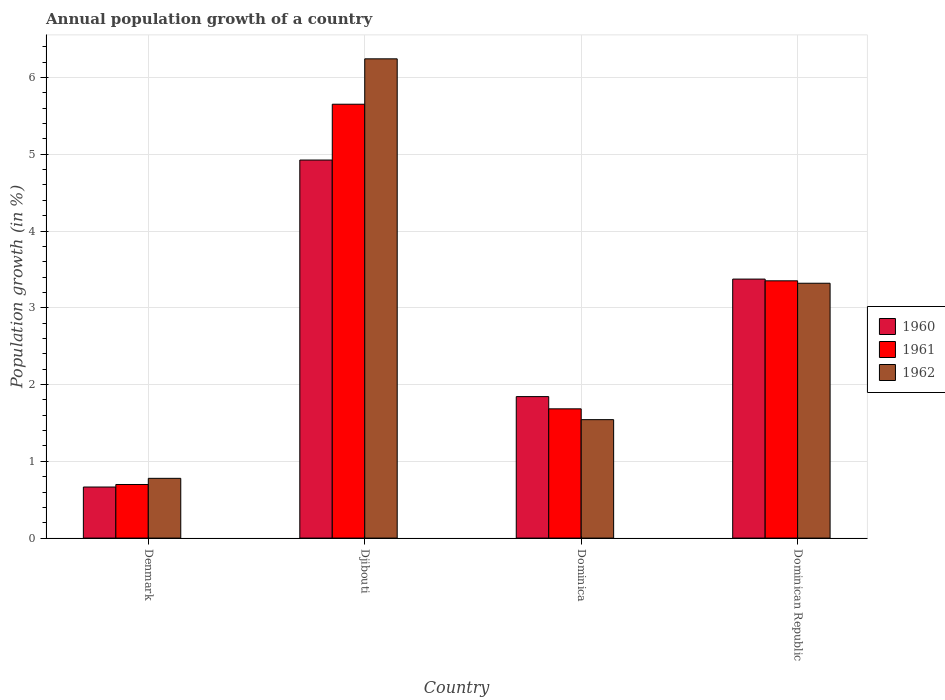How many different coloured bars are there?
Your answer should be very brief. 3. How many groups of bars are there?
Give a very brief answer. 4. How many bars are there on the 4th tick from the left?
Offer a very short reply. 3. What is the label of the 3rd group of bars from the left?
Offer a terse response. Dominica. What is the annual population growth in 1962 in Dominica?
Your answer should be compact. 1.54. Across all countries, what is the maximum annual population growth in 1961?
Give a very brief answer. 5.65. Across all countries, what is the minimum annual population growth in 1961?
Ensure brevity in your answer.  0.7. In which country was the annual population growth in 1961 maximum?
Provide a short and direct response. Djibouti. What is the total annual population growth in 1960 in the graph?
Offer a terse response. 10.81. What is the difference between the annual population growth in 1960 in Djibouti and that in Dominica?
Your answer should be very brief. 3.08. What is the difference between the annual population growth in 1960 in Dominican Republic and the annual population growth in 1962 in Dominica?
Make the answer very short. 1.83. What is the average annual population growth in 1961 per country?
Your answer should be very brief. 2.85. What is the difference between the annual population growth of/in 1962 and annual population growth of/in 1961 in Denmark?
Your answer should be very brief. 0.08. What is the ratio of the annual population growth in 1960 in Denmark to that in Djibouti?
Make the answer very short. 0.14. Is the difference between the annual population growth in 1962 in Dominica and Dominican Republic greater than the difference between the annual population growth in 1961 in Dominica and Dominican Republic?
Keep it short and to the point. No. What is the difference between the highest and the second highest annual population growth in 1961?
Your response must be concise. -1.67. What is the difference between the highest and the lowest annual population growth in 1961?
Make the answer very short. 4.95. How many bars are there?
Make the answer very short. 12. What is the difference between two consecutive major ticks on the Y-axis?
Offer a terse response. 1. Does the graph contain any zero values?
Offer a terse response. No. Does the graph contain grids?
Offer a terse response. Yes. How many legend labels are there?
Provide a succinct answer. 3. How are the legend labels stacked?
Offer a very short reply. Vertical. What is the title of the graph?
Ensure brevity in your answer.  Annual population growth of a country. What is the label or title of the X-axis?
Your answer should be compact. Country. What is the label or title of the Y-axis?
Your answer should be compact. Population growth (in %). What is the Population growth (in %) of 1960 in Denmark?
Make the answer very short. 0.67. What is the Population growth (in %) of 1961 in Denmark?
Ensure brevity in your answer.  0.7. What is the Population growth (in %) in 1962 in Denmark?
Offer a terse response. 0.78. What is the Population growth (in %) in 1960 in Djibouti?
Make the answer very short. 4.92. What is the Population growth (in %) of 1961 in Djibouti?
Offer a very short reply. 5.65. What is the Population growth (in %) in 1962 in Djibouti?
Offer a terse response. 6.24. What is the Population growth (in %) in 1960 in Dominica?
Offer a very short reply. 1.84. What is the Population growth (in %) in 1961 in Dominica?
Ensure brevity in your answer.  1.68. What is the Population growth (in %) in 1962 in Dominica?
Your answer should be compact. 1.54. What is the Population growth (in %) of 1960 in Dominican Republic?
Your answer should be compact. 3.37. What is the Population growth (in %) in 1961 in Dominican Republic?
Ensure brevity in your answer.  3.35. What is the Population growth (in %) of 1962 in Dominican Republic?
Provide a short and direct response. 3.32. Across all countries, what is the maximum Population growth (in %) of 1960?
Your answer should be compact. 4.92. Across all countries, what is the maximum Population growth (in %) in 1961?
Keep it short and to the point. 5.65. Across all countries, what is the maximum Population growth (in %) in 1962?
Give a very brief answer. 6.24. Across all countries, what is the minimum Population growth (in %) in 1960?
Ensure brevity in your answer.  0.67. Across all countries, what is the minimum Population growth (in %) in 1961?
Your response must be concise. 0.7. Across all countries, what is the minimum Population growth (in %) of 1962?
Make the answer very short. 0.78. What is the total Population growth (in %) of 1960 in the graph?
Make the answer very short. 10.81. What is the total Population growth (in %) of 1961 in the graph?
Provide a short and direct response. 11.38. What is the total Population growth (in %) in 1962 in the graph?
Your answer should be very brief. 11.88. What is the difference between the Population growth (in %) in 1960 in Denmark and that in Djibouti?
Offer a very short reply. -4.26. What is the difference between the Population growth (in %) in 1961 in Denmark and that in Djibouti?
Your answer should be compact. -4.95. What is the difference between the Population growth (in %) in 1962 in Denmark and that in Djibouti?
Provide a succinct answer. -5.46. What is the difference between the Population growth (in %) in 1960 in Denmark and that in Dominica?
Offer a terse response. -1.18. What is the difference between the Population growth (in %) of 1961 in Denmark and that in Dominica?
Your answer should be very brief. -0.99. What is the difference between the Population growth (in %) of 1962 in Denmark and that in Dominica?
Provide a succinct answer. -0.76. What is the difference between the Population growth (in %) of 1960 in Denmark and that in Dominican Republic?
Keep it short and to the point. -2.71. What is the difference between the Population growth (in %) in 1961 in Denmark and that in Dominican Republic?
Provide a succinct answer. -2.65. What is the difference between the Population growth (in %) of 1962 in Denmark and that in Dominican Republic?
Make the answer very short. -2.54. What is the difference between the Population growth (in %) in 1960 in Djibouti and that in Dominica?
Your answer should be very brief. 3.08. What is the difference between the Population growth (in %) of 1961 in Djibouti and that in Dominica?
Your response must be concise. 3.97. What is the difference between the Population growth (in %) in 1962 in Djibouti and that in Dominica?
Offer a very short reply. 4.7. What is the difference between the Population growth (in %) in 1960 in Djibouti and that in Dominican Republic?
Keep it short and to the point. 1.55. What is the difference between the Population growth (in %) in 1961 in Djibouti and that in Dominican Republic?
Your answer should be compact. 2.3. What is the difference between the Population growth (in %) in 1962 in Djibouti and that in Dominican Republic?
Make the answer very short. 2.92. What is the difference between the Population growth (in %) in 1960 in Dominica and that in Dominican Republic?
Keep it short and to the point. -1.53. What is the difference between the Population growth (in %) of 1961 in Dominica and that in Dominican Republic?
Your response must be concise. -1.67. What is the difference between the Population growth (in %) in 1962 in Dominica and that in Dominican Republic?
Your response must be concise. -1.78. What is the difference between the Population growth (in %) of 1960 in Denmark and the Population growth (in %) of 1961 in Djibouti?
Ensure brevity in your answer.  -4.99. What is the difference between the Population growth (in %) in 1960 in Denmark and the Population growth (in %) in 1962 in Djibouti?
Offer a very short reply. -5.58. What is the difference between the Population growth (in %) in 1961 in Denmark and the Population growth (in %) in 1962 in Djibouti?
Offer a terse response. -5.54. What is the difference between the Population growth (in %) of 1960 in Denmark and the Population growth (in %) of 1961 in Dominica?
Your response must be concise. -1.02. What is the difference between the Population growth (in %) in 1960 in Denmark and the Population growth (in %) in 1962 in Dominica?
Your answer should be compact. -0.88. What is the difference between the Population growth (in %) in 1961 in Denmark and the Population growth (in %) in 1962 in Dominica?
Offer a very short reply. -0.84. What is the difference between the Population growth (in %) of 1960 in Denmark and the Population growth (in %) of 1961 in Dominican Republic?
Make the answer very short. -2.69. What is the difference between the Population growth (in %) in 1960 in Denmark and the Population growth (in %) in 1962 in Dominican Republic?
Keep it short and to the point. -2.65. What is the difference between the Population growth (in %) in 1961 in Denmark and the Population growth (in %) in 1962 in Dominican Republic?
Provide a short and direct response. -2.62. What is the difference between the Population growth (in %) in 1960 in Djibouti and the Population growth (in %) in 1961 in Dominica?
Keep it short and to the point. 3.24. What is the difference between the Population growth (in %) in 1960 in Djibouti and the Population growth (in %) in 1962 in Dominica?
Ensure brevity in your answer.  3.38. What is the difference between the Population growth (in %) in 1961 in Djibouti and the Population growth (in %) in 1962 in Dominica?
Offer a very short reply. 4.11. What is the difference between the Population growth (in %) of 1960 in Djibouti and the Population growth (in %) of 1961 in Dominican Republic?
Offer a very short reply. 1.57. What is the difference between the Population growth (in %) of 1960 in Djibouti and the Population growth (in %) of 1962 in Dominican Republic?
Keep it short and to the point. 1.6. What is the difference between the Population growth (in %) in 1961 in Djibouti and the Population growth (in %) in 1962 in Dominican Republic?
Offer a terse response. 2.33. What is the difference between the Population growth (in %) in 1960 in Dominica and the Population growth (in %) in 1961 in Dominican Republic?
Keep it short and to the point. -1.51. What is the difference between the Population growth (in %) of 1960 in Dominica and the Population growth (in %) of 1962 in Dominican Republic?
Your answer should be very brief. -1.48. What is the difference between the Population growth (in %) of 1961 in Dominica and the Population growth (in %) of 1962 in Dominican Republic?
Give a very brief answer. -1.64. What is the average Population growth (in %) of 1960 per country?
Offer a very short reply. 2.7. What is the average Population growth (in %) in 1961 per country?
Your answer should be compact. 2.85. What is the average Population growth (in %) of 1962 per country?
Provide a succinct answer. 2.97. What is the difference between the Population growth (in %) in 1960 and Population growth (in %) in 1961 in Denmark?
Make the answer very short. -0.03. What is the difference between the Population growth (in %) in 1960 and Population growth (in %) in 1962 in Denmark?
Provide a short and direct response. -0.11. What is the difference between the Population growth (in %) in 1961 and Population growth (in %) in 1962 in Denmark?
Offer a terse response. -0.08. What is the difference between the Population growth (in %) of 1960 and Population growth (in %) of 1961 in Djibouti?
Your response must be concise. -0.73. What is the difference between the Population growth (in %) of 1960 and Population growth (in %) of 1962 in Djibouti?
Ensure brevity in your answer.  -1.32. What is the difference between the Population growth (in %) of 1961 and Population growth (in %) of 1962 in Djibouti?
Make the answer very short. -0.59. What is the difference between the Population growth (in %) of 1960 and Population growth (in %) of 1961 in Dominica?
Keep it short and to the point. 0.16. What is the difference between the Population growth (in %) in 1960 and Population growth (in %) in 1962 in Dominica?
Your answer should be compact. 0.3. What is the difference between the Population growth (in %) of 1961 and Population growth (in %) of 1962 in Dominica?
Keep it short and to the point. 0.14. What is the difference between the Population growth (in %) in 1960 and Population growth (in %) in 1961 in Dominican Republic?
Your answer should be compact. 0.02. What is the difference between the Population growth (in %) of 1960 and Population growth (in %) of 1962 in Dominican Republic?
Make the answer very short. 0.05. What is the difference between the Population growth (in %) in 1961 and Population growth (in %) in 1962 in Dominican Republic?
Offer a very short reply. 0.03. What is the ratio of the Population growth (in %) of 1960 in Denmark to that in Djibouti?
Your response must be concise. 0.14. What is the ratio of the Population growth (in %) in 1961 in Denmark to that in Djibouti?
Provide a short and direct response. 0.12. What is the ratio of the Population growth (in %) in 1962 in Denmark to that in Djibouti?
Make the answer very short. 0.12. What is the ratio of the Population growth (in %) in 1960 in Denmark to that in Dominica?
Your answer should be compact. 0.36. What is the ratio of the Population growth (in %) in 1961 in Denmark to that in Dominica?
Offer a very short reply. 0.41. What is the ratio of the Population growth (in %) in 1962 in Denmark to that in Dominica?
Your answer should be very brief. 0.5. What is the ratio of the Population growth (in %) in 1960 in Denmark to that in Dominican Republic?
Your answer should be compact. 0.2. What is the ratio of the Population growth (in %) of 1961 in Denmark to that in Dominican Republic?
Your answer should be compact. 0.21. What is the ratio of the Population growth (in %) in 1962 in Denmark to that in Dominican Republic?
Provide a short and direct response. 0.23. What is the ratio of the Population growth (in %) in 1960 in Djibouti to that in Dominica?
Your response must be concise. 2.67. What is the ratio of the Population growth (in %) of 1961 in Djibouti to that in Dominica?
Provide a succinct answer. 3.36. What is the ratio of the Population growth (in %) in 1962 in Djibouti to that in Dominica?
Your answer should be compact. 4.05. What is the ratio of the Population growth (in %) of 1960 in Djibouti to that in Dominican Republic?
Your answer should be very brief. 1.46. What is the ratio of the Population growth (in %) in 1961 in Djibouti to that in Dominican Republic?
Offer a terse response. 1.69. What is the ratio of the Population growth (in %) of 1962 in Djibouti to that in Dominican Republic?
Provide a succinct answer. 1.88. What is the ratio of the Population growth (in %) of 1960 in Dominica to that in Dominican Republic?
Provide a succinct answer. 0.55. What is the ratio of the Population growth (in %) in 1961 in Dominica to that in Dominican Republic?
Your answer should be compact. 0.5. What is the ratio of the Population growth (in %) in 1962 in Dominica to that in Dominican Republic?
Provide a short and direct response. 0.46. What is the difference between the highest and the second highest Population growth (in %) in 1960?
Offer a very short reply. 1.55. What is the difference between the highest and the second highest Population growth (in %) in 1961?
Give a very brief answer. 2.3. What is the difference between the highest and the second highest Population growth (in %) in 1962?
Ensure brevity in your answer.  2.92. What is the difference between the highest and the lowest Population growth (in %) of 1960?
Make the answer very short. 4.26. What is the difference between the highest and the lowest Population growth (in %) in 1961?
Your answer should be compact. 4.95. What is the difference between the highest and the lowest Population growth (in %) of 1962?
Give a very brief answer. 5.46. 